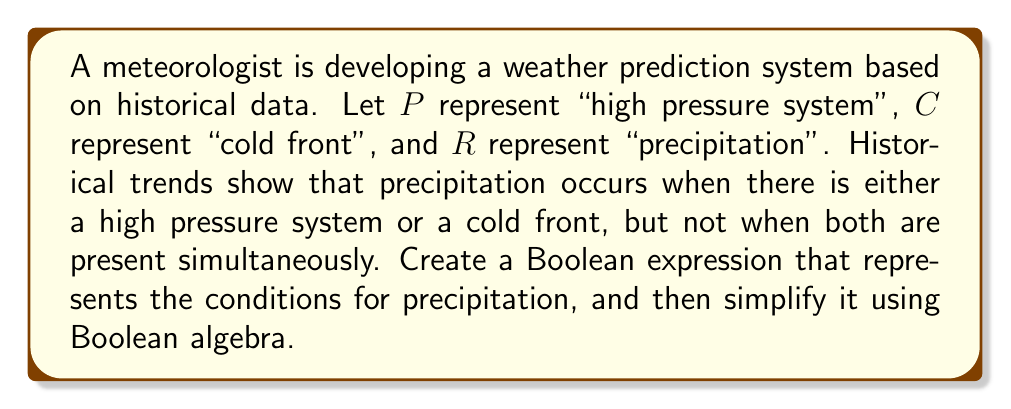Can you solve this math problem? Let's approach this step-by-step:

1) First, we need to translate the given information into a Boolean expression:
   - Precipitation occurs when there is a high pressure system OR a cold front
   - BUT NOT when both are present simultaneously

2) This can be represented as:
   $R = (P \lor C) \land \lnot(P \land C)$

3) Now, let's simplify this expression using Boolean algebra:
   
   $R = (P \lor C) \land \lnot(P \land C)$
   
   We can apply De Morgan's law to the second part:
   $R = (P \lor C) \land (\lnot P \lor \lnot C)$

4) Now we can use the distributive property:
   $R = (P \land \lnot P) \lor (P \land \lnot C) \lor (C \land \lnot P) \lor (C \land \lnot C)$

5) Simplify:
   - $(P \land \lnot P) = 0$ (false)
   - $(C \land \lnot C) = 0$ (false)

   So we're left with:
   $R = (P \land \lnot C) \lor (C \land \lnot P)$

6) This final expression is known as the "exclusive or" (XOR) of $P$ and $C$, often written as $P \oplus C$.

Therefore, the simplified Boolean expression for precipitation based on the given historical trends is $P \oplus C$.
Answer: $R = P \oplus C$ 